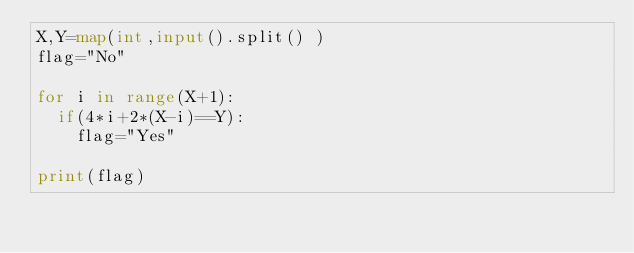Convert code to text. <code><loc_0><loc_0><loc_500><loc_500><_Python_>X,Y=map(int,input().split() )
flag="No"

for i in range(X+1):
  if(4*i+2*(X-i)==Y):
    flag="Yes"

print(flag)</code> 